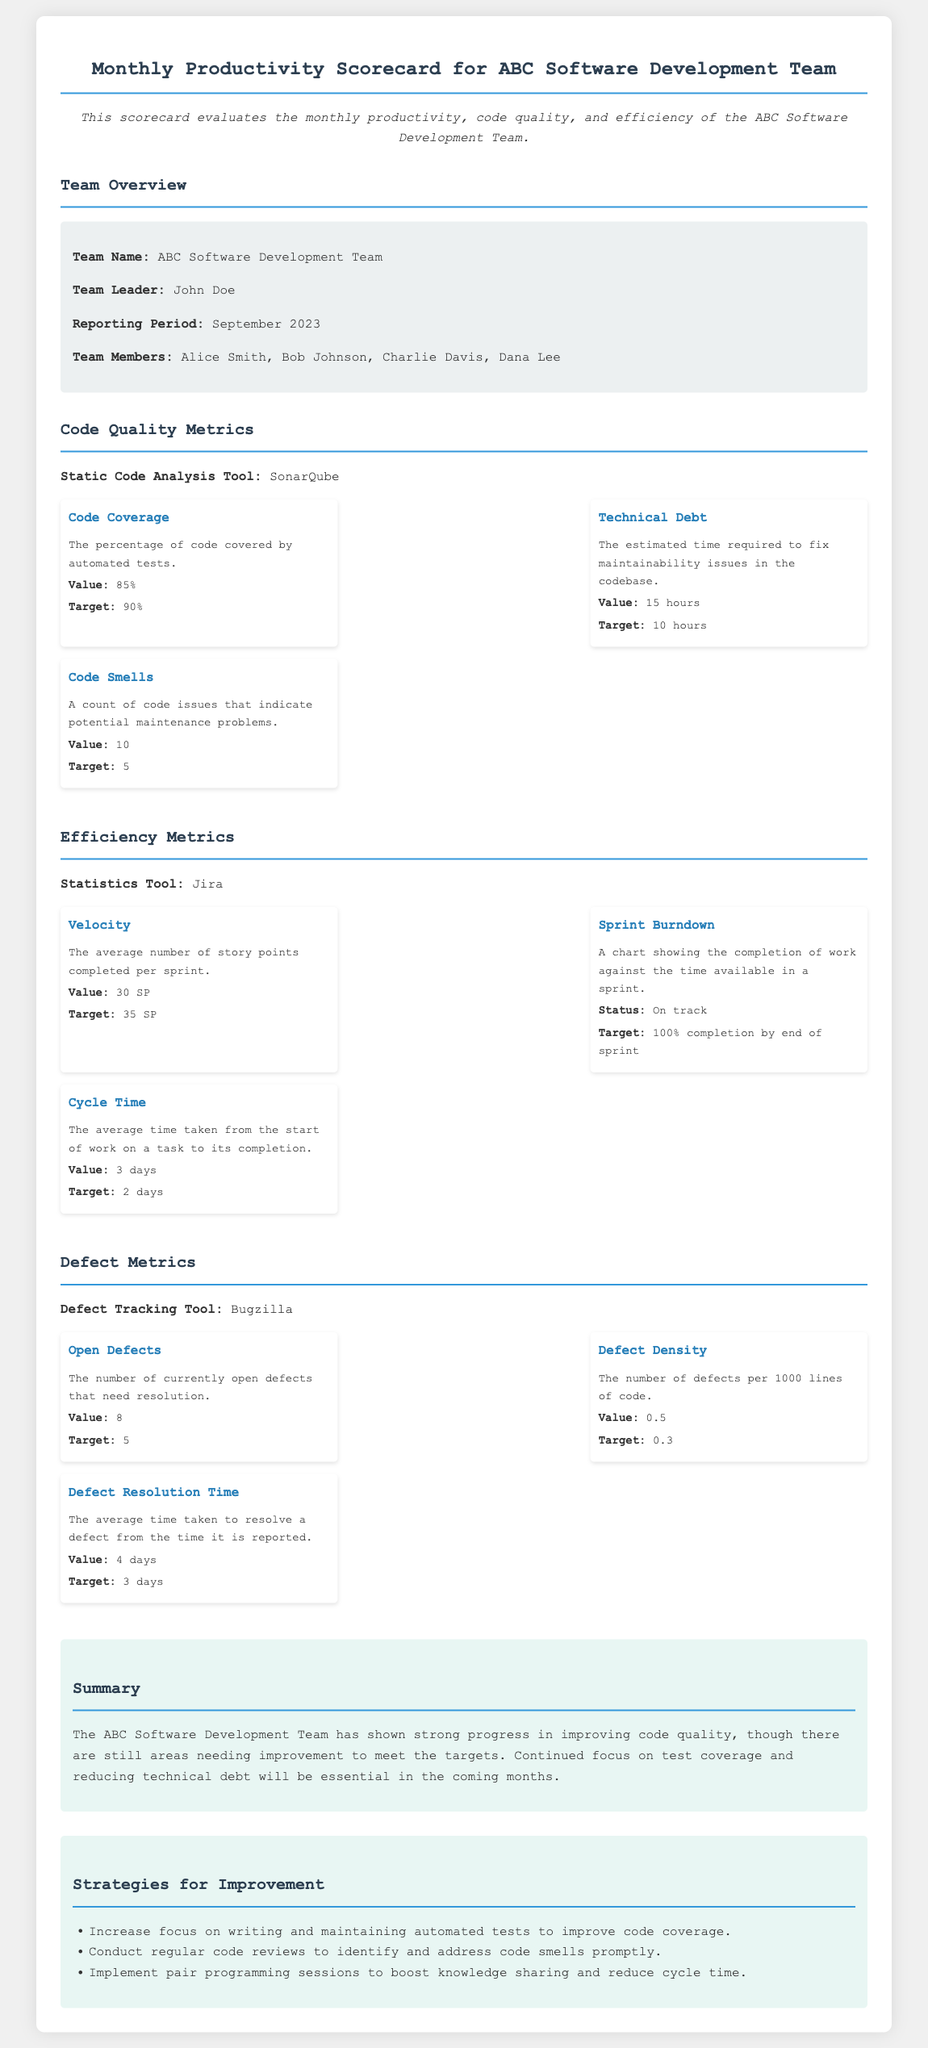What is the team name? The team name is listed in the team overview section of the document.
Answer: ABC Software Development Team Who is the team leader? The team leader is mentioned in the team overview section of the document.
Answer: John Doe What was the reporting period? The reporting period indicates the time frame for which metrics are reported.
Answer: September 2023 What is the value of code coverage? The value of code coverage is specified in the code quality metrics section.
Answer: 85% What is the target for defect density? The target for defect density is given in the defect metrics section of the document.
Answer: 0.3 How many open defects are there? The current number of open defects is included in the defect metrics section.
Answer: 8 What is the average cycle time? The average cycle time is provided in the efficiency metrics section of the document.
Answer: 3 days What improvement strategy focuses on automated tests? This improvement strategy emphasizes enhancing coding practices mentioned in the strategies for improvement section.
Answer: Increase focus on writing and maintaining automated tests to improve code coverage What tool is used for static code analysis? The tool used for static code analysis is referenced in the code quality metrics section.
Answer: SonarQube 